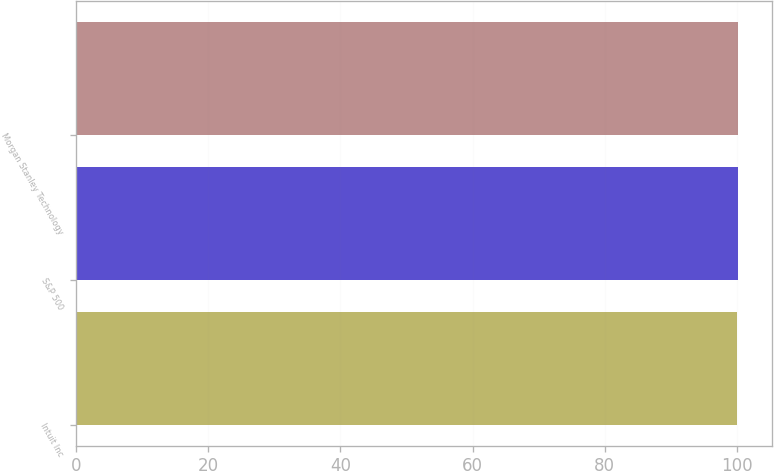<chart> <loc_0><loc_0><loc_500><loc_500><bar_chart><fcel>Intuit Inc<fcel>S&P 500<fcel>Morgan Stanley Technology<nl><fcel>100<fcel>100.1<fcel>100.2<nl></chart> 